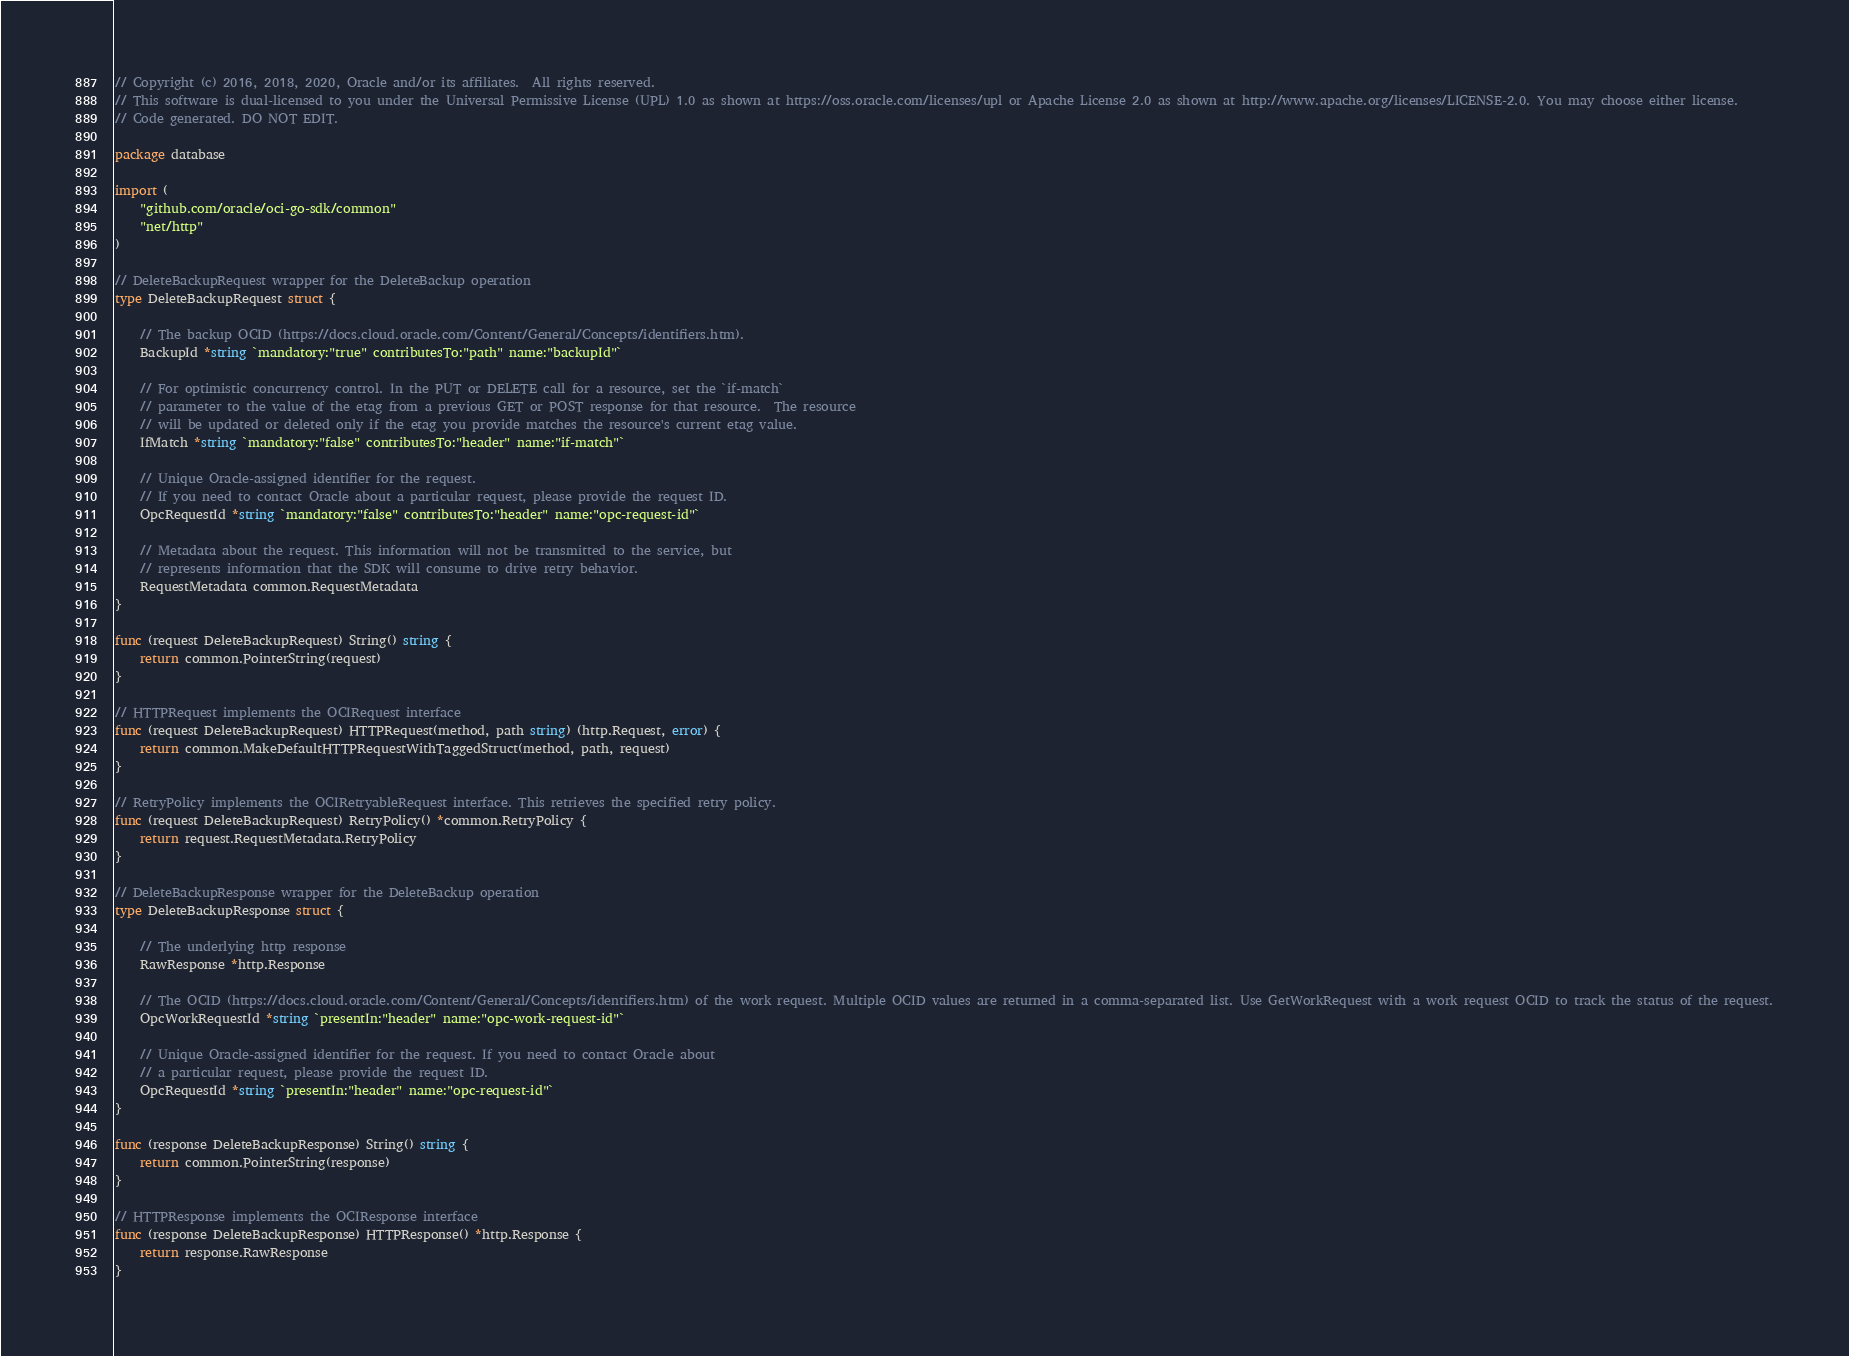Convert code to text. <code><loc_0><loc_0><loc_500><loc_500><_Go_>// Copyright (c) 2016, 2018, 2020, Oracle and/or its affiliates.  All rights reserved.
// This software is dual-licensed to you under the Universal Permissive License (UPL) 1.0 as shown at https://oss.oracle.com/licenses/upl or Apache License 2.0 as shown at http://www.apache.org/licenses/LICENSE-2.0. You may choose either license.
// Code generated. DO NOT EDIT.

package database

import (
	"github.com/oracle/oci-go-sdk/common"
	"net/http"
)

// DeleteBackupRequest wrapper for the DeleteBackup operation
type DeleteBackupRequest struct {

	// The backup OCID (https://docs.cloud.oracle.com/Content/General/Concepts/identifiers.htm).
	BackupId *string `mandatory:"true" contributesTo:"path" name:"backupId"`

	// For optimistic concurrency control. In the PUT or DELETE call for a resource, set the `if-match`
	// parameter to the value of the etag from a previous GET or POST response for that resource.  The resource
	// will be updated or deleted only if the etag you provide matches the resource's current etag value.
	IfMatch *string `mandatory:"false" contributesTo:"header" name:"if-match"`

	// Unique Oracle-assigned identifier for the request.
	// If you need to contact Oracle about a particular request, please provide the request ID.
	OpcRequestId *string `mandatory:"false" contributesTo:"header" name:"opc-request-id"`

	// Metadata about the request. This information will not be transmitted to the service, but
	// represents information that the SDK will consume to drive retry behavior.
	RequestMetadata common.RequestMetadata
}

func (request DeleteBackupRequest) String() string {
	return common.PointerString(request)
}

// HTTPRequest implements the OCIRequest interface
func (request DeleteBackupRequest) HTTPRequest(method, path string) (http.Request, error) {
	return common.MakeDefaultHTTPRequestWithTaggedStruct(method, path, request)
}

// RetryPolicy implements the OCIRetryableRequest interface. This retrieves the specified retry policy.
func (request DeleteBackupRequest) RetryPolicy() *common.RetryPolicy {
	return request.RequestMetadata.RetryPolicy
}

// DeleteBackupResponse wrapper for the DeleteBackup operation
type DeleteBackupResponse struct {

	// The underlying http response
	RawResponse *http.Response

	// The OCID (https://docs.cloud.oracle.com/Content/General/Concepts/identifiers.htm) of the work request. Multiple OCID values are returned in a comma-separated list. Use GetWorkRequest with a work request OCID to track the status of the request.
	OpcWorkRequestId *string `presentIn:"header" name:"opc-work-request-id"`

	// Unique Oracle-assigned identifier for the request. If you need to contact Oracle about
	// a particular request, please provide the request ID.
	OpcRequestId *string `presentIn:"header" name:"opc-request-id"`
}

func (response DeleteBackupResponse) String() string {
	return common.PointerString(response)
}

// HTTPResponse implements the OCIResponse interface
func (response DeleteBackupResponse) HTTPResponse() *http.Response {
	return response.RawResponse
}
</code> 